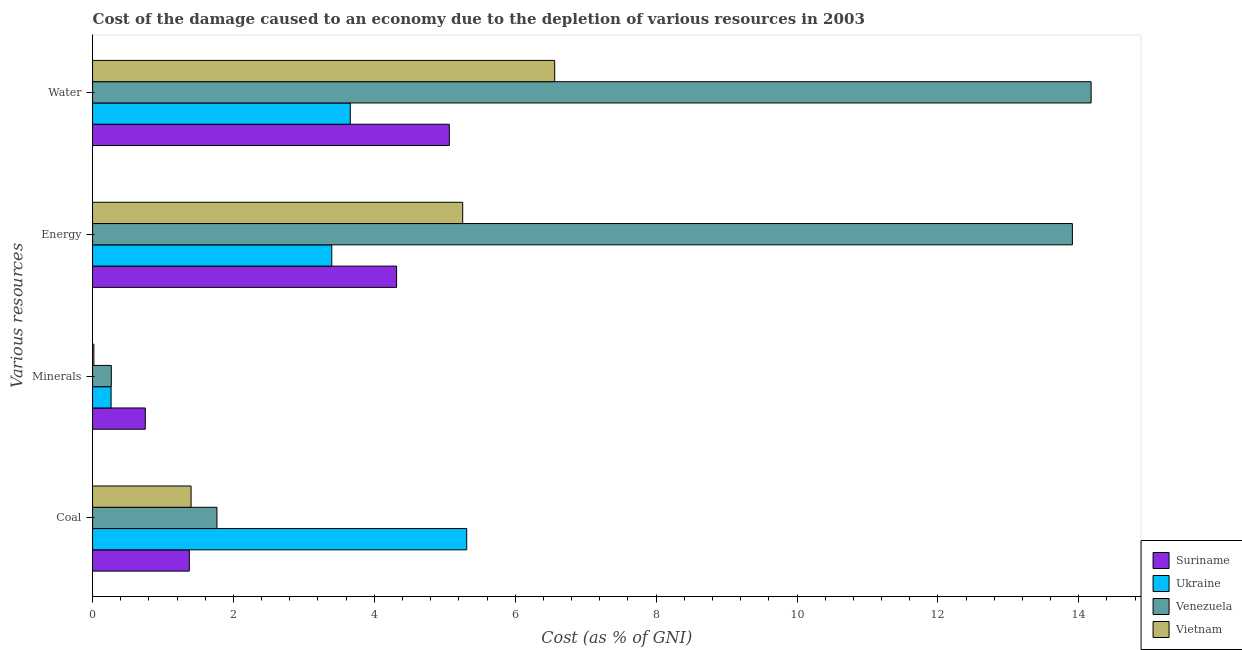Are the number of bars per tick equal to the number of legend labels?
Ensure brevity in your answer.  Yes. How many bars are there on the 2nd tick from the top?
Offer a terse response. 4. What is the label of the 2nd group of bars from the top?
Offer a terse response. Energy. What is the cost of damage due to depletion of water in Ukraine?
Give a very brief answer. 3.66. Across all countries, what is the maximum cost of damage due to depletion of coal?
Give a very brief answer. 5.31. Across all countries, what is the minimum cost of damage due to depletion of minerals?
Provide a succinct answer. 0.02. In which country was the cost of damage due to depletion of water maximum?
Provide a short and direct response. Venezuela. In which country was the cost of damage due to depletion of coal minimum?
Give a very brief answer. Suriname. What is the total cost of damage due to depletion of energy in the graph?
Keep it short and to the point. 26.87. What is the difference between the cost of damage due to depletion of energy in Suriname and that in Vietnam?
Ensure brevity in your answer.  -0.94. What is the difference between the cost of damage due to depletion of coal in Suriname and the cost of damage due to depletion of water in Ukraine?
Your response must be concise. -2.28. What is the average cost of damage due to depletion of minerals per country?
Provide a succinct answer. 0.32. What is the difference between the cost of damage due to depletion of minerals and cost of damage due to depletion of energy in Vietnam?
Give a very brief answer. -5.24. In how many countries, is the cost of damage due to depletion of water greater than 14.4 %?
Make the answer very short. 0. What is the ratio of the cost of damage due to depletion of energy in Vietnam to that in Ukraine?
Offer a very short reply. 1.55. Is the cost of damage due to depletion of water in Ukraine less than that in Vietnam?
Offer a very short reply. Yes. What is the difference between the highest and the second highest cost of damage due to depletion of minerals?
Ensure brevity in your answer.  0.48. What is the difference between the highest and the lowest cost of damage due to depletion of energy?
Your answer should be very brief. 10.51. In how many countries, is the cost of damage due to depletion of minerals greater than the average cost of damage due to depletion of minerals taken over all countries?
Keep it short and to the point. 1. What does the 3rd bar from the top in Coal represents?
Provide a short and direct response. Ukraine. What does the 2nd bar from the bottom in Energy represents?
Provide a short and direct response. Ukraine. Is it the case that in every country, the sum of the cost of damage due to depletion of coal and cost of damage due to depletion of minerals is greater than the cost of damage due to depletion of energy?
Ensure brevity in your answer.  No. Are all the bars in the graph horizontal?
Ensure brevity in your answer.  Yes. What is the difference between two consecutive major ticks on the X-axis?
Your response must be concise. 2. Does the graph contain any zero values?
Give a very brief answer. No. Does the graph contain grids?
Keep it short and to the point. No. Where does the legend appear in the graph?
Your answer should be compact. Bottom right. How are the legend labels stacked?
Offer a very short reply. Vertical. What is the title of the graph?
Give a very brief answer. Cost of the damage caused to an economy due to the depletion of various resources in 2003 . What is the label or title of the X-axis?
Offer a terse response. Cost (as % of GNI). What is the label or title of the Y-axis?
Make the answer very short. Various resources. What is the Cost (as % of GNI) of Suriname in Coal?
Your answer should be very brief. 1.37. What is the Cost (as % of GNI) of Ukraine in Coal?
Give a very brief answer. 5.31. What is the Cost (as % of GNI) of Venezuela in Coal?
Offer a terse response. 1.77. What is the Cost (as % of GNI) in Vietnam in Coal?
Give a very brief answer. 1.4. What is the Cost (as % of GNI) in Suriname in Minerals?
Offer a very short reply. 0.75. What is the Cost (as % of GNI) in Ukraine in Minerals?
Provide a short and direct response. 0.26. What is the Cost (as % of GNI) of Venezuela in Minerals?
Offer a very short reply. 0.27. What is the Cost (as % of GNI) in Vietnam in Minerals?
Your answer should be very brief. 0.02. What is the Cost (as % of GNI) in Suriname in Energy?
Provide a short and direct response. 4.32. What is the Cost (as % of GNI) in Ukraine in Energy?
Make the answer very short. 3.4. What is the Cost (as % of GNI) in Venezuela in Energy?
Your answer should be compact. 13.91. What is the Cost (as % of GNI) in Vietnam in Energy?
Keep it short and to the point. 5.25. What is the Cost (as % of GNI) in Suriname in Water?
Offer a terse response. 5.06. What is the Cost (as % of GNI) in Ukraine in Water?
Offer a very short reply. 3.66. What is the Cost (as % of GNI) in Venezuela in Water?
Your response must be concise. 14.17. What is the Cost (as % of GNI) in Vietnam in Water?
Provide a short and direct response. 6.56. Across all Various resources, what is the maximum Cost (as % of GNI) in Suriname?
Give a very brief answer. 5.06. Across all Various resources, what is the maximum Cost (as % of GNI) of Ukraine?
Your response must be concise. 5.31. Across all Various resources, what is the maximum Cost (as % of GNI) in Venezuela?
Make the answer very short. 14.17. Across all Various resources, what is the maximum Cost (as % of GNI) in Vietnam?
Ensure brevity in your answer.  6.56. Across all Various resources, what is the minimum Cost (as % of GNI) of Suriname?
Provide a short and direct response. 0.75. Across all Various resources, what is the minimum Cost (as % of GNI) in Ukraine?
Offer a very short reply. 0.26. Across all Various resources, what is the minimum Cost (as % of GNI) in Venezuela?
Offer a very short reply. 0.27. Across all Various resources, what is the minimum Cost (as % of GNI) in Vietnam?
Offer a terse response. 0.02. What is the total Cost (as % of GNI) of Suriname in the graph?
Your answer should be compact. 11.5. What is the total Cost (as % of GNI) in Ukraine in the graph?
Offer a terse response. 12.63. What is the total Cost (as % of GNI) in Venezuela in the graph?
Make the answer very short. 30.12. What is the total Cost (as % of GNI) of Vietnam in the graph?
Offer a very short reply. 13.23. What is the difference between the Cost (as % of GNI) of Ukraine in Coal and that in Minerals?
Make the answer very short. 5.05. What is the difference between the Cost (as % of GNI) of Venezuela in Coal and that in Minerals?
Give a very brief answer. 1.5. What is the difference between the Cost (as % of GNI) in Vietnam in Coal and that in Minerals?
Provide a succinct answer. 1.38. What is the difference between the Cost (as % of GNI) in Suriname in Coal and that in Energy?
Your answer should be compact. -2.94. What is the difference between the Cost (as % of GNI) in Ukraine in Coal and that in Energy?
Offer a very short reply. 1.92. What is the difference between the Cost (as % of GNI) in Venezuela in Coal and that in Energy?
Make the answer very short. -12.14. What is the difference between the Cost (as % of GNI) in Vietnam in Coal and that in Energy?
Provide a short and direct response. -3.86. What is the difference between the Cost (as % of GNI) of Suriname in Coal and that in Water?
Your response must be concise. -3.69. What is the difference between the Cost (as % of GNI) of Ukraine in Coal and that in Water?
Keep it short and to the point. 1.65. What is the difference between the Cost (as % of GNI) in Venezuela in Coal and that in Water?
Keep it short and to the point. -12.41. What is the difference between the Cost (as % of GNI) in Vietnam in Coal and that in Water?
Provide a succinct answer. -5.16. What is the difference between the Cost (as % of GNI) in Suriname in Minerals and that in Energy?
Provide a succinct answer. -3.57. What is the difference between the Cost (as % of GNI) of Ukraine in Minerals and that in Energy?
Your answer should be very brief. -3.13. What is the difference between the Cost (as % of GNI) in Venezuela in Minerals and that in Energy?
Make the answer very short. -13.64. What is the difference between the Cost (as % of GNI) in Vietnam in Minerals and that in Energy?
Your answer should be compact. -5.24. What is the difference between the Cost (as % of GNI) in Suriname in Minerals and that in Water?
Make the answer very short. -4.32. What is the difference between the Cost (as % of GNI) in Ukraine in Minerals and that in Water?
Offer a terse response. -3.4. What is the difference between the Cost (as % of GNI) in Venezuela in Minerals and that in Water?
Your answer should be compact. -13.91. What is the difference between the Cost (as % of GNI) in Vietnam in Minerals and that in Water?
Give a very brief answer. -6.54. What is the difference between the Cost (as % of GNI) of Suriname in Energy and that in Water?
Offer a very short reply. -0.75. What is the difference between the Cost (as % of GNI) of Ukraine in Energy and that in Water?
Keep it short and to the point. -0.26. What is the difference between the Cost (as % of GNI) of Venezuela in Energy and that in Water?
Make the answer very short. -0.27. What is the difference between the Cost (as % of GNI) of Vietnam in Energy and that in Water?
Make the answer very short. -1.31. What is the difference between the Cost (as % of GNI) in Suriname in Coal and the Cost (as % of GNI) in Ukraine in Minerals?
Keep it short and to the point. 1.11. What is the difference between the Cost (as % of GNI) of Suriname in Coal and the Cost (as % of GNI) of Venezuela in Minerals?
Provide a short and direct response. 1.11. What is the difference between the Cost (as % of GNI) in Suriname in Coal and the Cost (as % of GNI) in Vietnam in Minerals?
Your answer should be compact. 1.35. What is the difference between the Cost (as % of GNI) of Ukraine in Coal and the Cost (as % of GNI) of Venezuela in Minerals?
Keep it short and to the point. 5.05. What is the difference between the Cost (as % of GNI) of Ukraine in Coal and the Cost (as % of GNI) of Vietnam in Minerals?
Make the answer very short. 5.29. What is the difference between the Cost (as % of GNI) of Venezuela in Coal and the Cost (as % of GNI) of Vietnam in Minerals?
Keep it short and to the point. 1.75. What is the difference between the Cost (as % of GNI) of Suriname in Coal and the Cost (as % of GNI) of Ukraine in Energy?
Your response must be concise. -2.02. What is the difference between the Cost (as % of GNI) in Suriname in Coal and the Cost (as % of GNI) in Venezuela in Energy?
Your response must be concise. -12.54. What is the difference between the Cost (as % of GNI) of Suriname in Coal and the Cost (as % of GNI) of Vietnam in Energy?
Make the answer very short. -3.88. What is the difference between the Cost (as % of GNI) in Ukraine in Coal and the Cost (as % of GNI) in Venezuela in Energy?
Provide a short and direct response. -8.6. What is the difference between the Cost (as % of GNI) of Ukraine in Coal and the Cost (as % of GNI) of Vietnam in Energy?
Your response must be concise. 0.06. What is the difference between the Cost (as % of GNI) in Venezuela in Coal and the Cost (as % of GNI) in Vietnam in Energy?
Your answer should be very brief. -3.49. What is the difference between the Cost (as % of GNI) of Suriname in Coal and the Cost (as % of GNI) of Ukraine in Water?
Provide a short and direct response. -2.28. What is the difference between the Cost (as % of GNI) of Suriname in Coal and the Cost (as % of GNI) of Venezuela in Water?
Give a very brief answer. -12.8. What is the difference between the Cost (as % of GNI) of Suriname in Coal and the Cost (as % of GNI) of Vietnam in Water?
Give a very brief answer. -5.19. What is the difference between the Cost (as % of GNI) in Ukraine in Coal and the Cost (as % of GNI) in Venezuela in Water?
Give a very brief answer. -8.86. What is the difference between the Cost (as % of GNI) of Ukraine in Coal and the Cost (as % of GNI) of Vietnam in Water?
Provide a short and direct response. -1.25. What is the difference between the Cost (as % of GNI) in Venezuela in Coal and the Cost (as % of GNI) in Vietnam in Water?
Your answer should be compact. -4.79. What is the difference between the Cost (as % of GNI) in Suriname in Minerals and the Cost (as % of GNI) in Ukraine in Energy?
Your response must be concise. -2.65. What is the difference between the Cost (as % of GNI) in Suriname in Minerals and the Cost (as % of GNI) in Venezuela in Energy?
Make the answer very short. -13.16. What is the difference between the Cost (as % of GNI) of Suriname in Minerals and the Cost (as % of GNI) of Vietnam in Energy?
Make the answer very short. -4.51. What is the difference between the Cost (as % of GNI) of Ukraine in Minerals and the Cost (as % of GNI) of Venezuela in Energy?
Provide a succinct answer. -13.65. What is the difference between the Cost (as % of GNI) of Ukraine in Minerals and the Cost (as % of GNI) of Vietnam in Energy?
Provide a short and direct response. -4.99. What is the difference between the Cost (as % of GNI) in Venezuela in Minerals and the Cost (as % of GNI) in Vietnam in Energy?
Your answer should be compact. -4.99. What is the difference between the Cost (as % of GNI) in Suriname in Minerals and the Cost (as % of GNI) in Ukraine in Water?
Keep it short and to the point. -2.91. What is the difference between the Cost (as % of GNI) in Suriname in Minerals and the Cost (as % of GNI) in Venezuela in Water?
Keep it short and to the point. -13.43. What is the difference between the Cost (as % of GNI) of Suriname in Minerals and the Cost (as % of GNI) of Vietnam in Water?
Offer a very short reply. -5.81. What is the difference between the Cost (as % of GNI) in Ukraine in Minerals and the Cost (as % of GNI) in Venezuela in Water?
Offer a very short reply. -13.91. What is the difference between the Cost (as % of GNI) of Ukraine in Minerals and the Cost (as % of GNI) of Vietnam in Water?
Your answer should be compact. -6.3. What is the difference between the Cost (as % of GNI) in Venezuela in Minerals and the Cost (as % of GNI) in Vietnam in Water?
Offer a terse response. -6.29. What is the difference between the Cost (as % of GNI) of Suriname in Energy and the Cost (as % of GNI) of Ukraine in Water?
Offer a very short reply. 0.66. What is the difference between the Cost (as % of GNI) of Suriname in Energy and the Cost (as % of GNI) of Venezuela in Water?
Keep it short and to the point. -9.86. What is the difference between the Cost (as % of GNI) of Suriname in Energy and the Cost (as % of GNI) of Vietnam in Water?
Ensure brevity in your answer.  -2.24. What is the difference between the Cost (as % of GNI) in Ukraine in Energy and the Cost (as % of GNI) in Venezuela in Water?
Provide a succinct answer. -10.78. What is the difference between the Cost (as % of GNI) of Ukraine in Energy and the Cost (as % of GNI) of Vietnam in Water?
Your response must be concise. -3.16. What is the difference between the Cost (as % of GNI) in Venezuela in Energy and the Cost (as % of GNI) in Vietnam in Water?
Offer a terse response. 7.35. What is the average Cost (as % of GNI) of Suriname per Various resources?
Offer a very short reply. 2.88. What is the average Cost (as % of GNI) of Ukraine per Various resources?
Make the answer very short. 3.16. What is the average Cost (as % of GNI) in Venezuela per Various resources?
Make the answer very short. 7.53. What is the average Cost (as % of GNI) in Vietnam per Various resources?
Give a very brief answer. 3.31. What is the difference between the Cost (as % of GNI) in Suriname and Cost (as % of GNI) in Ukraine in Coal?
Give a very brief answer. -3.94. What is the difference between the Cost (as % of GNI) of Suriname and Cost (as % of GNI) of Venezuela in Coal?
Provide a succinct answer. -0.39. What is the difference between the Cost (as % of GNI) of Suriname and Cost (as % of GNI) of Vietnam in Coal?
Your response must be concise. -0.02. What is the difference between the Cost (as % of GNI) of Ukraine and Cost (as % of GNI) of Venezuela in Coal?
Provide a short and direct response. 3.55. What is the difference between the Cost (as % of GNI) in Ukraine and Cost (as % of GNI) in Vietnam in Coal?
Make the answer very short. 3.91. What is the difference between the Cost (as % of GNI) in Venezuela and Cost (as % of GNI) in Vietnam in Coal?
Offer a terse response. 0.37. What is the difference between the Cost (as % of GNI) in Suriname and Cost (as % of GNI) in Ukraine in Minerals?
Ensure brevity in your answer.  0.49. What is the difference between the Cost (as % of GNI) of Suriname and Cost (as % of GNI) of Venezuela in Minerals?
Ensure brevity in your answer.  0.48. What is the difference between the Cost (as % of GNI) of Suriname and Cost (as % of GNI) of Vietnam in Minerals?
Offer a terse response. 0.73. What is the difference between the Cost (as % of GNI) of Ukraine and Cost (as % of GNI) of Venezuela in Minerals?
Your answer should be compact. -0. What is the difference between the Cost (as % of GNI) of Ukraine and Cost (as % of GNI) of Vietnam in Minerals?
Keep it short and to the point. 0.24. What is the difference between the Cost (as % of GNI) of Venezuela and Cost (as % of GNI) of Vietnam in Minerals?
Provide a succinct answer. 0.25. What is the difference between the Cost (as % of GNI) of Suriname and Cost (as % of GNI) of Ukraine in Energy?
Provide a short and direct response. 0.92. What is the difference between the Cost (as % of GNI) in Suriname and Cost (as % of GNI) in Venezuela in Energy?
Give a very brief answer. -9.59. What is the difference between the Cost (as % of GNI) of Suriname and Cost (as % of GNI) of Vietnam in Energy?
Give a very brief answer. -0.94. What is the difference between the Cost (as % of GNI) of Ukraine and Cost (as % of GNI) of Venezuela in Energy?
Provide a succinct answer. -10.51. What is the difference between the Cost (as % of GNI) of Ukraine and Cost (as % of GNI) of Vietnam in Energy?
Make the answer very short. -1.86. What is the difference between the Cost (as % of GNI) in Venezuela and Cost (as % of GNI) in Vietnam in Energy?
Offer a terse response. 8.65. What is the difference between the Cost (as % of GNI) in Suriname and Cost (as % of GNI) in Ukraine in Water?
Ensure brevity in your answer.  1.41. What is the difference between the Cost (as % of GNI) of Suriname and Cost (as % of GNI) of Venezuela in Water?
Provide a succinct answer. -9.11. What is the difference between the Cost (as % of GNI) in Suriname and Cost (as % of GNI) in Vietnam in Water?
Offer a terse response. -1.5. What is the difference between the Cost (as % of GNI) in Ukraine and Cost (as % of GNI) in Venezuela in Water?
Keep it short and to the point. -10.52. What is the difference between the Cost (as % of GNI) in Ukraine and Cost (as % of GNI) in Vietnam in Water?
Provide a succinct answer. -2.9. What is the difference between the Cost (as % of GNI) of Venezuela and Cost (as % of GNI) of Vietnam in Water?
Provide a short and direct response. 7.62. What is the ratio of the Cost (as % of GNI) of Suriname in Coal to that in Minerals?
Your response must be concise. 1.83. What is the ratio of the Cost (as % of GNI) of Ukraine in Coal to that in Minerals?
Your answer should be very brief. 20.2. What is the ratio of the Cost (as % of GNI) in Venezuela in Coal to that in Minerals?
Keep it short and to the point. 6.64. What is the ratio of the Cost (as % of GNI) of Vietnam in Coal to that in Minerals?
Ensure brevity in your answer.  74.69. What is the ratio of the Cost (as % of GNI) of Suriname in Coal to that in Energy?
Provide a succinct answer. 0.32. What is the ratio of the Cost (as % of GNI) in Ukraine in Coal to that in Energy?
Your response must be concise. 1.56. What is the ratio of the Cost (as % of GNI) in Venezuela in Coal to that in Energy?
Give a very brief answer. 0.13. What is the ratio of the Cost (as % of GNI) in Vietnam in Coal to that in Energy?
Your answer should be very brief. 0.27. What is the ratio of the Cost (as % of GNI) of Suriname in Coal to that in Water?
Provide a succinct answer. 0.27. What is the ratio of the Cost (as % of GNI) of Ukraine in Coal to that in Water?
Offer a very short reply. 1.45. What is the ratio of the Cost (as % of GNI) in Venezuela in Coal to that in Water?
Your response must be concise. 0.12. What is the ratio of the Cost (as % of GNI) in Vietnam in Coal to that in Water?
Provide a succinct answer. 0.21. What is the ratio of the Cost (as % of GNI) in Suriname in Minerals to that in Energy?
Your response must be concise. 0.17. What is the ratio of the Cost (as % of GNI) of Ukraine in Minerals to that in Energy?
Offer a terse response. 0.08. What is the ratio of the Cost (as % of GNI) in Venezuela in Minerals to that in Energy?
Provide a short and direct response. 0.02. What is the ratio of the Cost (as % of GNI) in Vietnam in Minerals to that in Energy?
Offer a terse response. 0. What is the ratio of the Cost (as % of GNI) in Suriname in Minerals to that in Water?
Make the answer very short. 0.15. What is the ratio of the Cost (as % of GNI) of Ukraine in Minerals to that in Water?
Your response must be concise. 0.07. What is the ratio of the Cost (as % of GNI) in Venezuela in Minerals to that in Water?
Make the answer very short. 0.02. What is the ratio of the Cost (as % of GNI) of Vietnam in Minerals to that in Water?
Make the answer very short. 0. What is the ratio of the Cost (as % of GNI) of Suriname in Energy to that in Water?
Your answer should be very brief. 0.85. What is the ratio of the Cost (as % of GNI) in Ukraine in Energy to that in Water?
Your answer should be compact. 0.93. What is the ratio of the Cost (as % of GNI) in Venezuela in Energy to that in Water?
Your answer should be compact. 0.98. What is the ratio of the Cost (as % of GNI) of Vietnam in Energy to that in Water?
Provide a short and direct response. 0.8. What is the difference between the highest and the second highest Cost (as % of GNI) of Suriname?
Make the answer very short. 0.75. What is the difference between the highest and the second highest Cost (as % of GNI) in Ukraine?
Your answer should be compact. 1.65. What is the difference between the highest and the second highest Cost (as % of GNI) in Venezuela?
Your response must be concise. 0.27. What is the difference between the highest and the second highest Cost (as % of GNI) in Vietnam?
Offer a terse response. 1.31. What is the difference between the highest and the lowest Cost (as % of GNI) of Suriname?
Keep it short and to the point. 4.32. What is the difference between the highest and the lowest Cost (as % of GNI) in Ukraine?
Offer a very short reply. 5.05. What is the difference between the highest and the lowest Cost (as % of GNI) of Venezuela?
Offer a terse response. 13.91. What is the difference between the highest and the lowest Cost (as % of GNI) of Vietnam?
Offer a terse response. 6.54. 